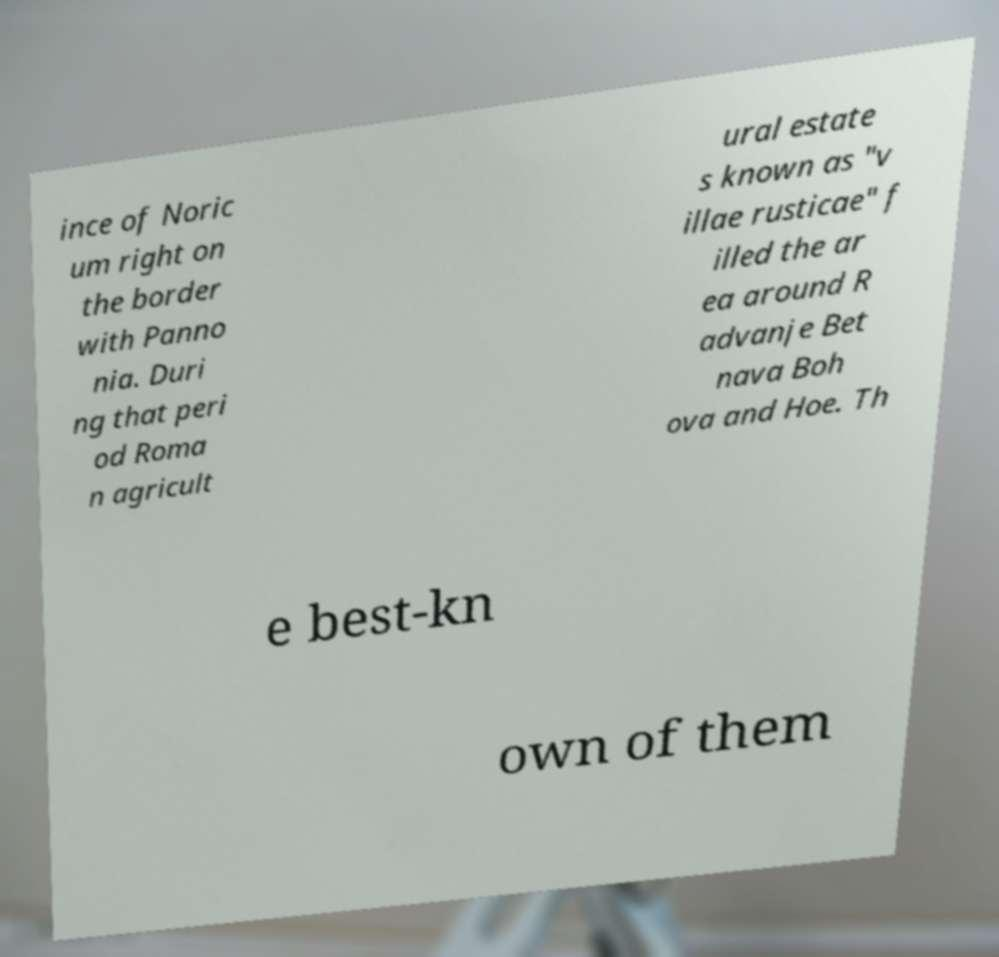There's text embedded in this image that I need extracted. Can you transcribe it verbatim? ince of Noric um right on the border with Panno nia. Duri ng that peri od Roma n agricult ural estate s known as "v illae rusticae" f illed the ar ea around R advanje Bet nava Boh ova and Hoe. Th e best-kn own of them 